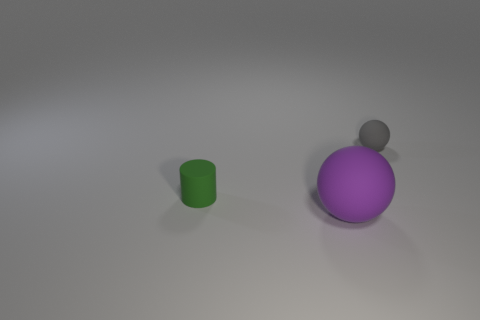How many other large objects have the same shape as the gray rubber object?
Your response must be concise. 1. Is the number of small cylinders in front of the green cylinder greater than the number of large purple matte balls left of the purple sphere?
Your answer should be compact. No. Do the large matte sphere and the small object that is to the right of the big purple thing have the same color?
Provide a short and direct response. No. There is a sphere that is the same size as the cylinder; what is it made of?
Offer a very short reply. Rubber. How many objects are tiny cyan metal cylinders or matte objects that are behind the small green matte cylinder?
Give a very brief answer. 1. Do the green object and the matte sphere in front of the gray thing have the same size?
Your answer should be compact. No. What number of cubes are either red metallic things or green objects?
Offer a terse response. 0. What number of things are both in front of the small gray matte object and on the right side of the green rubber cylinder?
Make the answer very short. 1. There is a small object that is left of the big ball; what shape is it?
Keep it short and to the point. Cylinder. Do the big thing and the cylinder have the same material?
Offer a very short reply. Yes. 